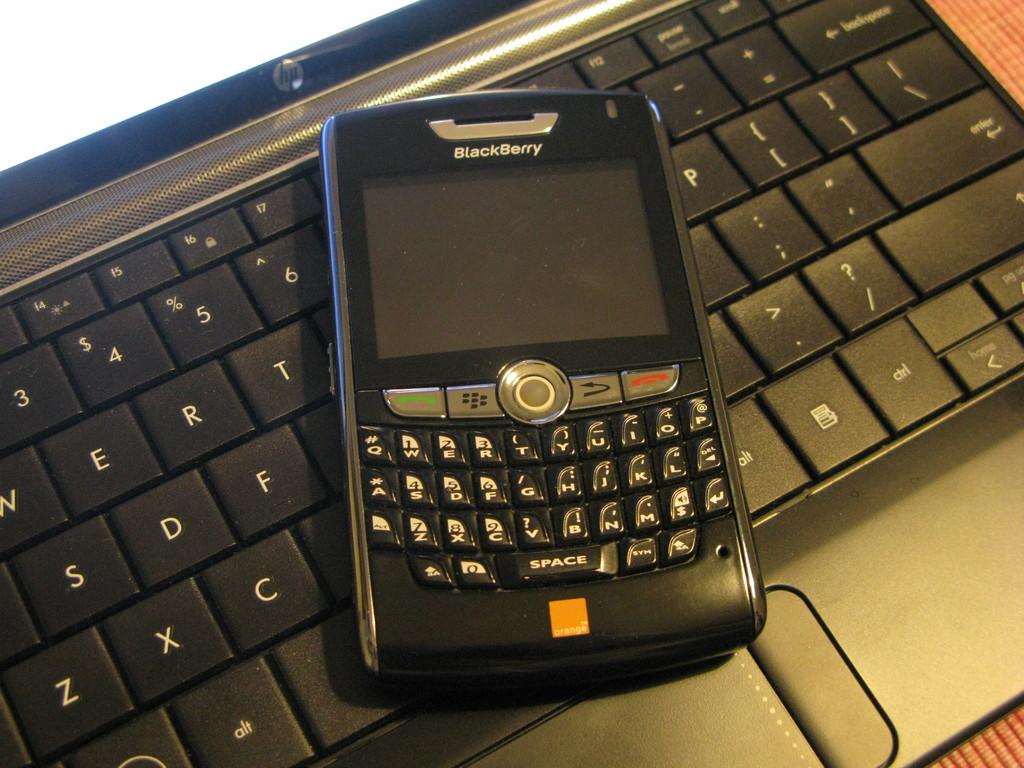What company makes this phone?
Offer a very short reply. Blackberry. 